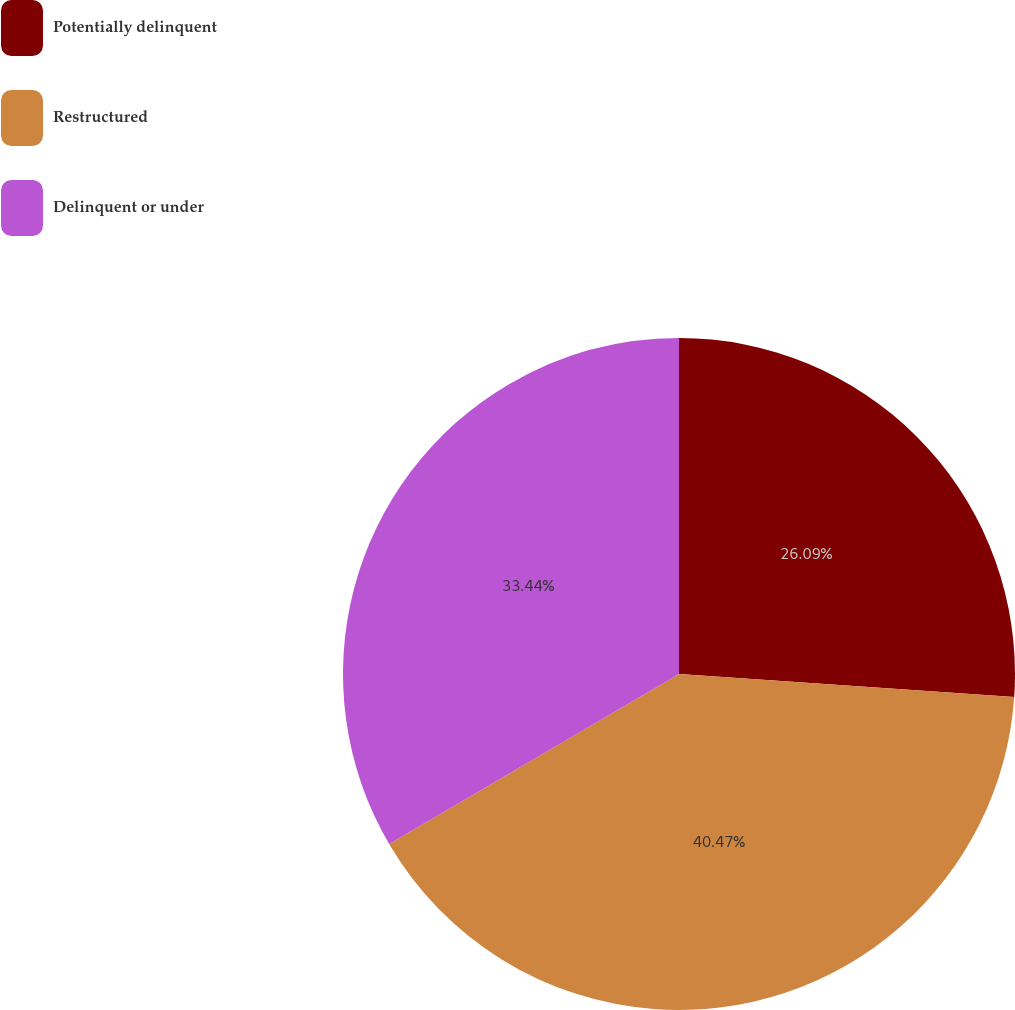<chart> <loc_0><loc_0><loc_500><loc_500><pie_chart><fcel>Potentially delinquent<fcel>Restructured<fcel>Delinquent or under<nl><fcel>26.09%<fcel>40.47%<fcel>33.44%<nl></chart> 